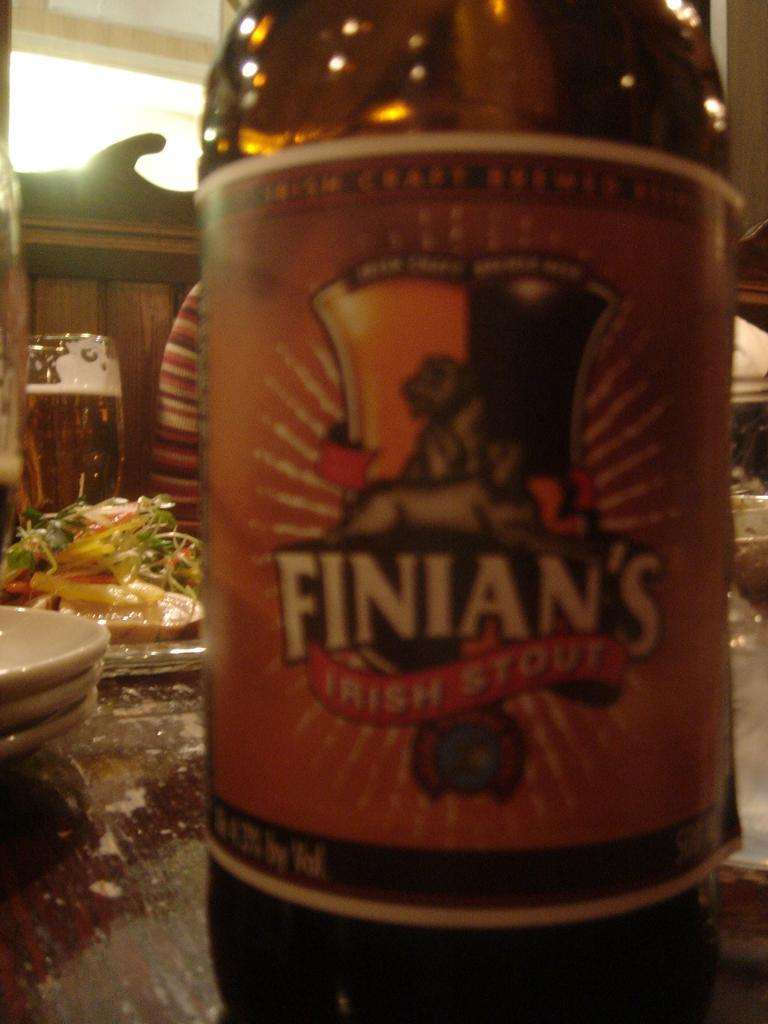<image>
Describe the image concisely. A Finian's Irish Stout beer bottle is on a restaurant table with lots of food on plates. 